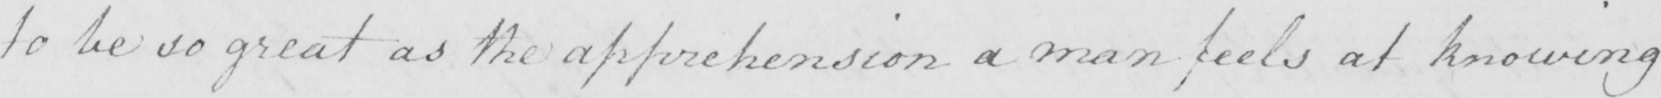Can you read and transcribe this handwriting? to be so great as the apprehension a man feels at knowing 